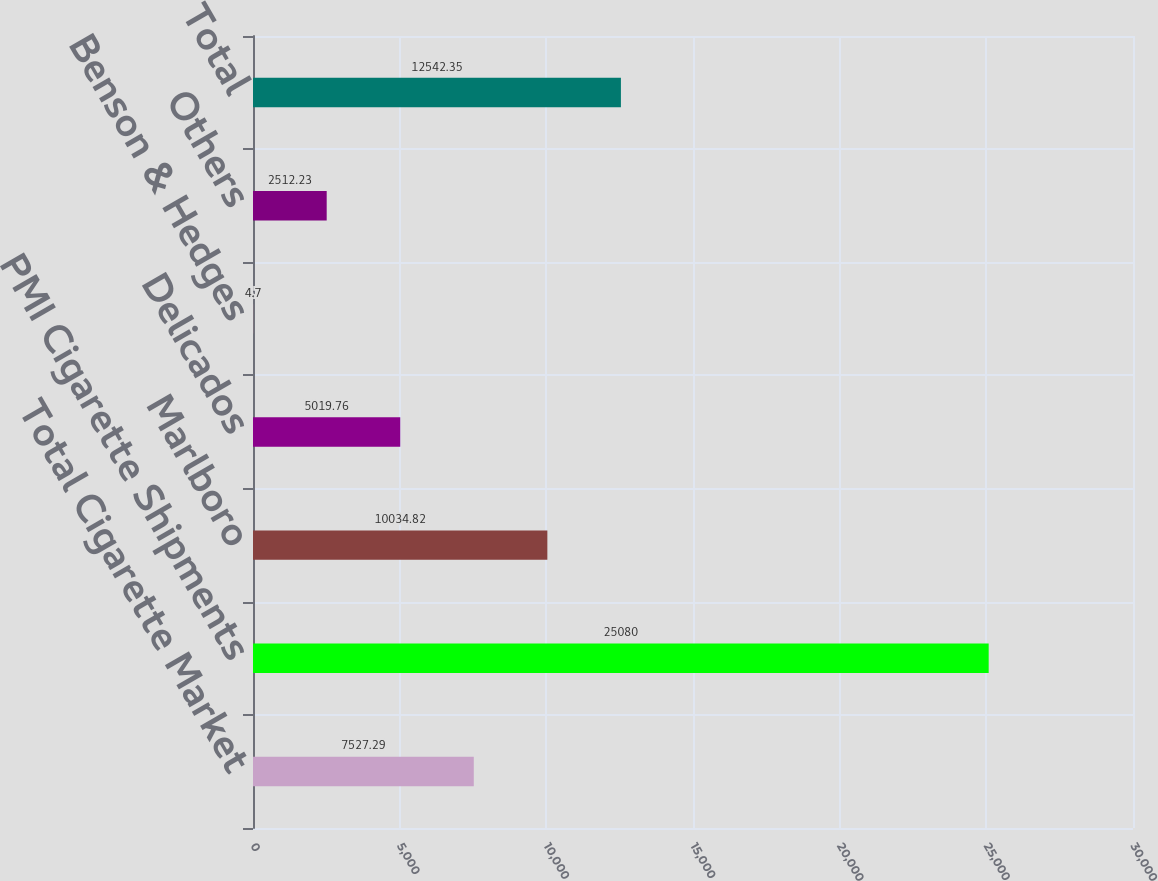Convert chart. <chart><loc_0><loc_0><loc_500><loc_500><bar_chart><fcel>Total Cigarette Market<fcel>PMI Cigarette Shipments<fcel>Marlboro<fcel>Delicados<fcel>Benson & Hedges<fcel>Others<fcel>Total<nl><fcel>7527.29<fcel>25080<fcel>10034.8<fcel>5019.76<fcel>4.7<fcel>2512.23<fcel>12542.4<nl></chart> 